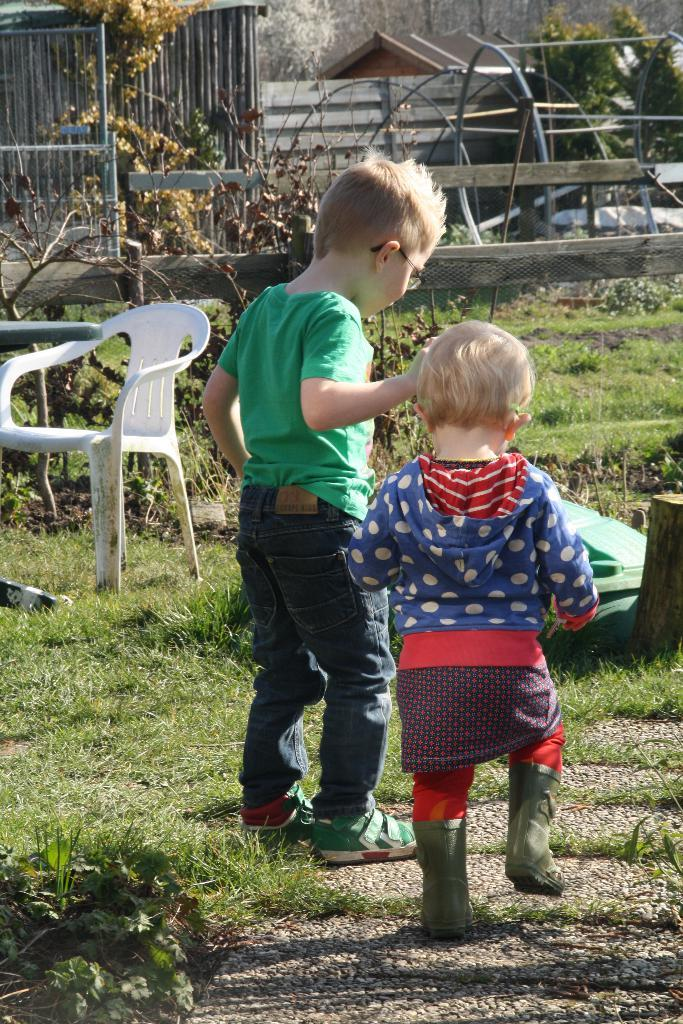Who are the people in the image? There is a boy and a small girl in the image. What are the boy and girl doing in the image? The boy and girl are standing. What object can be seen in the image that is typically used for sitting? There is a chair in the image. What type of natural environment is visible in the image? There are trees in the image. What type of road can be seen in the image? There is no road present in the image. What effect does the dock have on the water in the image? There is no dock present in the image, so it cannot have any effect on the water. 